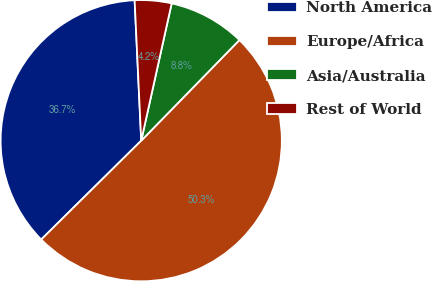Convert chart to OTSL. <chart><loc_0><loc_0><loc_500><loc_500><pie_chart><fcel>North America<fcel>Europe/Africa<fcel>Asia/Australia<fcel>Rest of World<nl><fcel>36.66%<fcel>50.29%<fcel>8.83%<fcel>4.22%<nl></chart> 